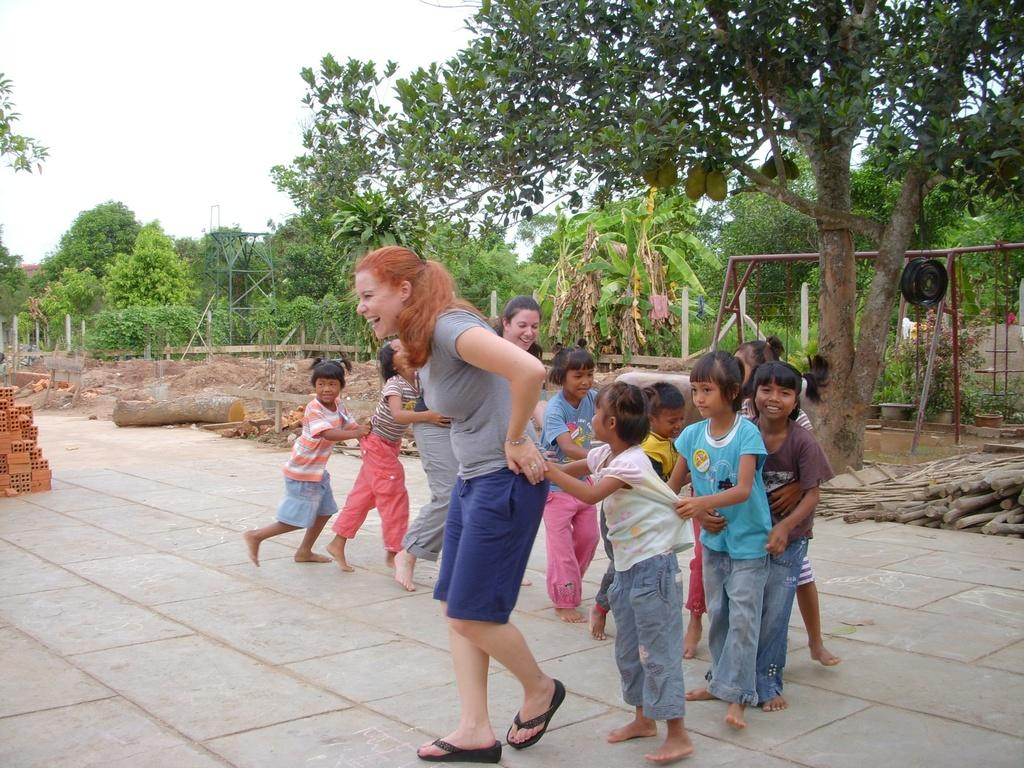What are the kids doing in the image? The kids are holding each other in the image. Who is in front of the kids in the image? A woman is walking in the front. What type of surface is the woman walking on? The woman is walking on land. What type of vegetation can be seen in the image? There are many plants and trees in the image. What is visible above the land and vegetation? The sky is visible above. What type of pies are being served at the religious ceremony in the image? There is no mention of pies or a religious ceremony in the image; it features kids holding each other and a woman walking in front. What type of disease is affecting the trees in the image? There is no indication of any disease affecting the trees in the image; they appear to be healthy. 